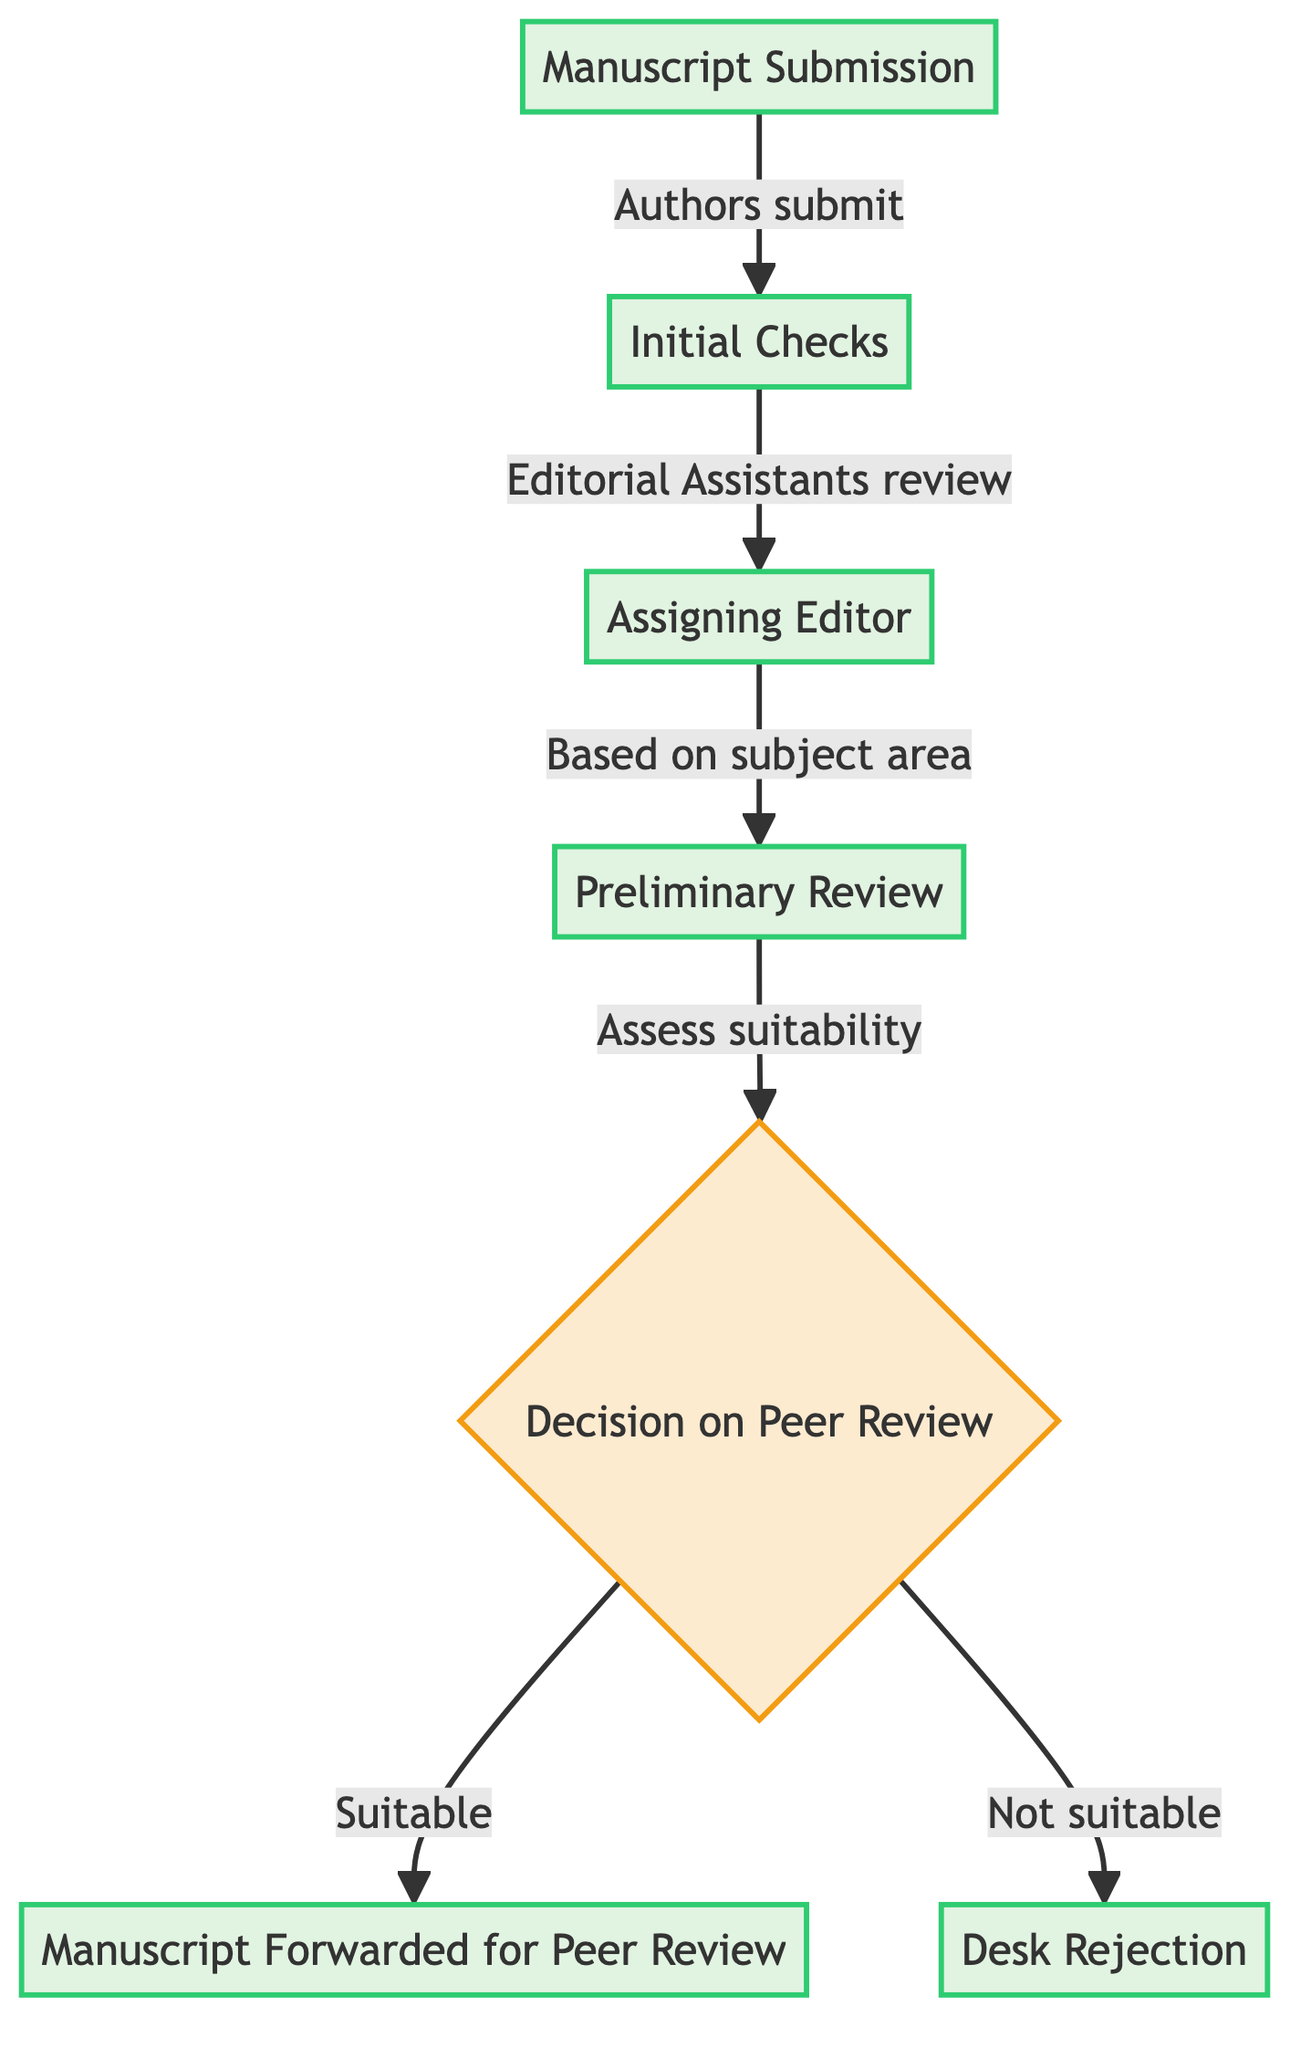What is the first step in the manuscript submission process? The first step in the diagram is "Manuscript Submission," where authors submit their manuscripts through the journal's online submission system.
Answer: Manuscript Submission How many main steps are there in the flowchart? The flowchart consists of 7 main steps, including manuscript submission and various review stages.
Answer: 7 Who conducts the initial checks for manuscript completeness? The diagram specifies that "Editorial Assistants" are responsible for performing initial checks for completeness and adherence to submission guidelines.
Answer: Editorial Assistants What decision does the assigned editor make after the preliminary review? After the preliminary review, the assigned editor makes a decision on whether to send the manuscript for peer review or desk reject it, which is indicated in the diagram as "Decision on Peer Review."
Answer: Decision on Peer Review If a manuscript is desk rejected, who receives the notification? The diagram indicates that if a manuscript is desk rejected, a rejection is sent to the "Authors."
Answer: Authors What is forwarded for peer review? If the manuscript is deemed suitable, it is "Manuscript Forwarded for Peer Review" to selected external reviewers, as per the flow of the diagram.
Answer: Manuscript Forwarded for Peer Review What triggers the process of assigning an editor? The process of assigning an editor is triggered after "Initial Checks" are completed, leading to the "Assigning Editor" step based on the subject area.
Answer: Assigning Editor What is the outcome if the manuscript is not suitable for the journal? If the manuscript is determined to be not suitable for the journal, the outcome is a "Desk Rejection," which is indicated in the diagram as a direct result of the decision made by the assigned editor.
Answer: Desk Rejection 